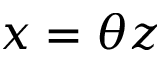Convert formula to latex. <formula><loc_0><loc_0><loc_500><loc_500>x = \theta z</formula> 